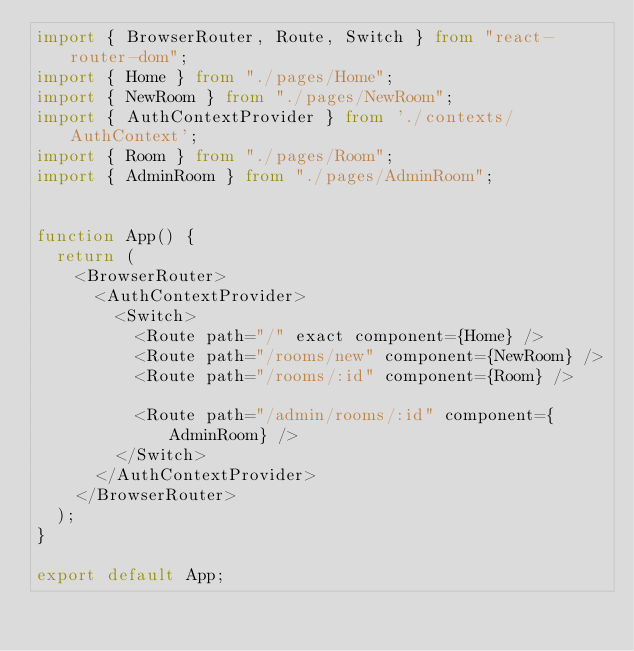Convert code to text. <code><loc_0><loc_0><loc_500><loc_500><_TypeScript_>import { BrowserRouter, Route, Switch } from "react-router-dom";
import { Home } from "./pages/Home";
import { NewRoom } from "./pages/NewRoom";
import { AuthContextProvider } from './contexts/AuthContext';
import { Room } from "./pages/Room";
import { AdminRoom } from "./pages/AdminRoom";


function App() {
  return (
    <BrowserRouter>
      <AuthContextProvider>
        <Switch>
          <Route path="/" exact component={Home} />
          <Route path="/rooms/new" component={NewRoom} />
          <Route path="/rooms/:id" component={Room} />

          <Route path="/admin/rooms/:id" component={AdminRoom} />
        </Switch>
      </AuthContextProvider>
    </BrowserRouter>
  );
}

export default App;
</code> 